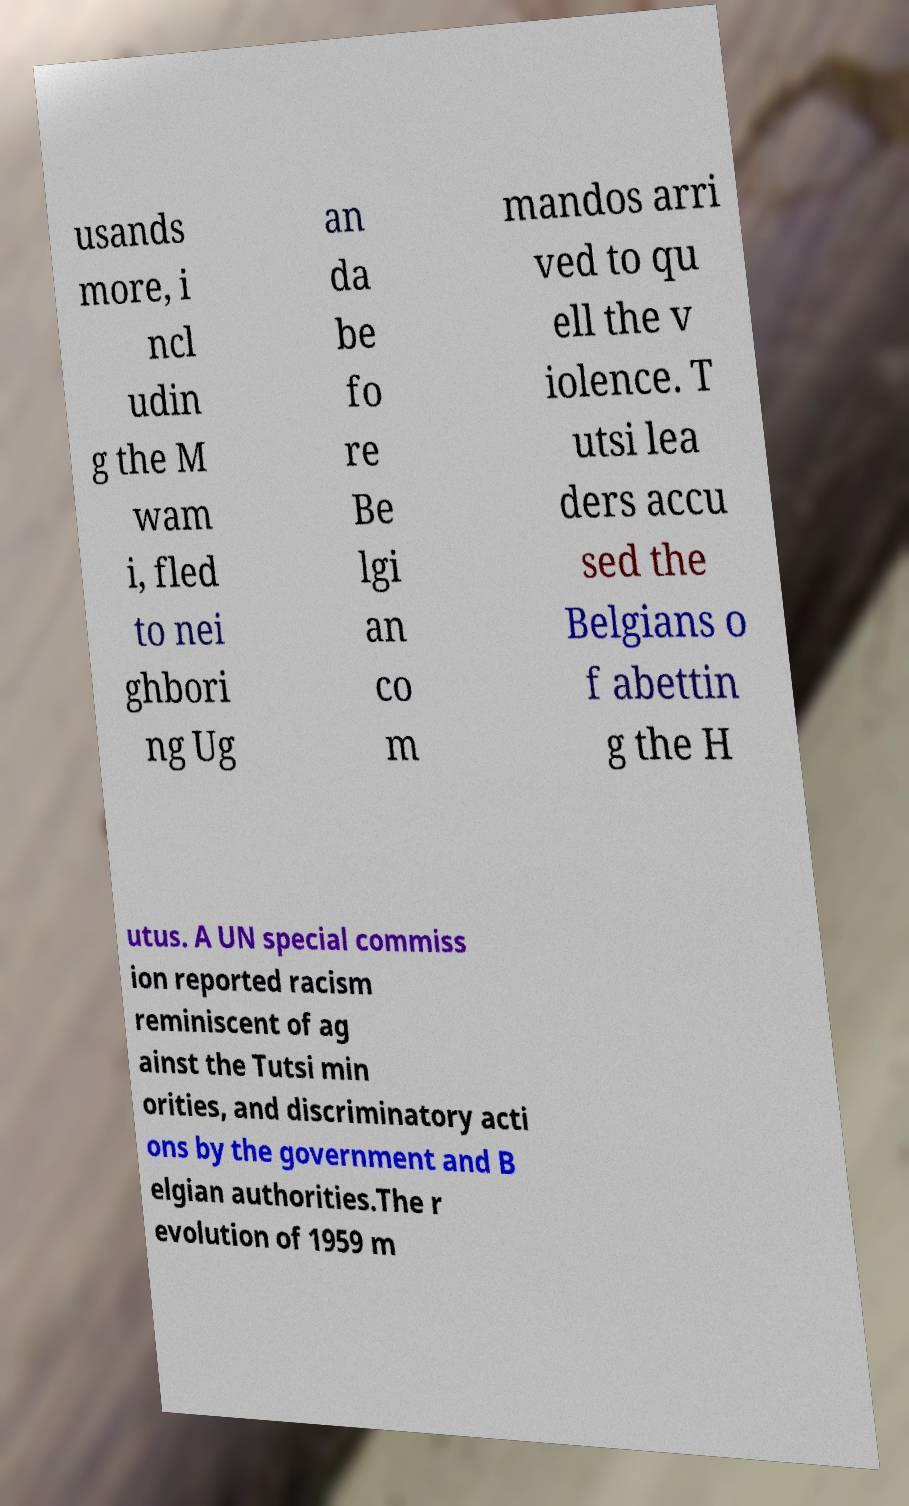There's text embedded in this image that I need extracted. Can you transcribe it verbatim? usands more, i ncl udin g the M wam i, fled to nei ghbori ng Ug an da be fo re Be lgi an co m mandos arri ved to qu ell the v iolence. T utsi lea ders accu sed the Belgians o f abettin g the H utus. A UN special commiss ion reported racism reminiscent of ag ainst the Tutsi min orities, and discriminatory acti ons by the government and B elgian authorities.The r evolution of 1959 m 